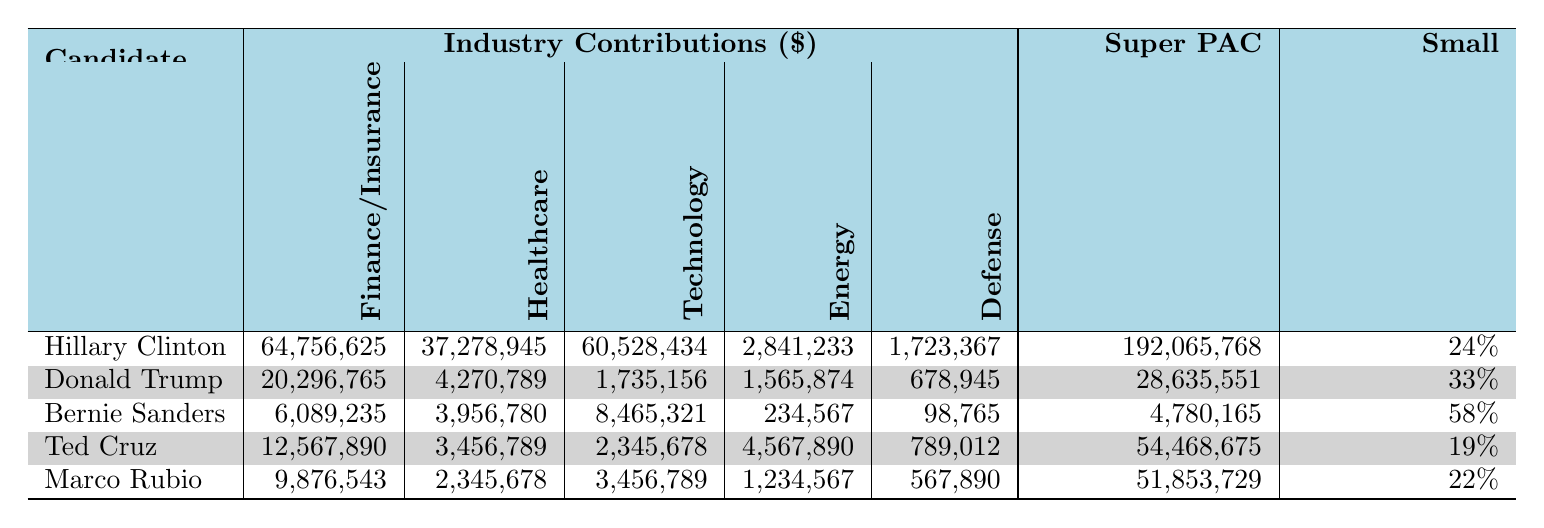What is the total contribution from the Finance/Insurance industry for Hillary Clinton? The table shows that Hillary Clinton received 64,756,625 from the Finance/Insurance industry.
Answer: 64,756,625 Which candidate received the least amount from the Healthcare industry? In the table, Bernie Sanders received 3,956,780, which is the lowest compared to other candidates.
Answer: Bernie Sanders What is the total contribution from the Technology industry for all candidates combined? Adding up the contributions from the Technology industry: 60,528,434 + 1,735,156 + 8,465,321 + 2,345,678 + 3,456,789 = 76,531,378.
Answer: 76,531,378 Did any candidate receive more than 50 million from the Energy industry? Looking at the Energy contributions, the highest is Ted Cruz with 4,567,890, which does not exceed 50 million.
Answer: No Which candidate has the highest percentage of small donations? The table shows Bernie Sanders with 58% for small donations, which is the highest compared to others.
Answer: Bernie Sanders What is the difference between the total contributions from the Defense industry for Hillary Clinton and Marco Rubio? Hillary Clinton received 1,723,367 and Marco Rubio received 567,890. The difference is 1,723,367 - 567,890 = 1,155,477.
Answer: 1,155,477 What percentage of small donations did Ted Cruz receive? The table indicates that Ted Cruz received 19% of his contributions as small donations.
Answer: 19% What is the average total raised by the Super PACs for the candidates? Calculating the total raised by all Super PACs: 192,065,768 + 28,635,551 + 4,780,165 + 54,468,675 + 51,853,729 = 331,903,888, and dividing by 5 gives an average of 331,903,888 / 5 = 66,380,777.6.
Answer: 66,380,777.6 Which candidate has the lowest total amount raised by their Super PAC? Donald Trump has the lowest total raised, which is 28,635,551.
Answer: Donald Trump Is the total contribution for Hillary Clinton from the Healthcare industry greater than the total contribution for Ted Cruz from the Defense industry? Hillary Clinton received 37,278,945 from Healthcare, while Ted Cruz received 789,012 from Defense. Since 37,278,945 > 789,012, the statement is true.
Answer: Yes 